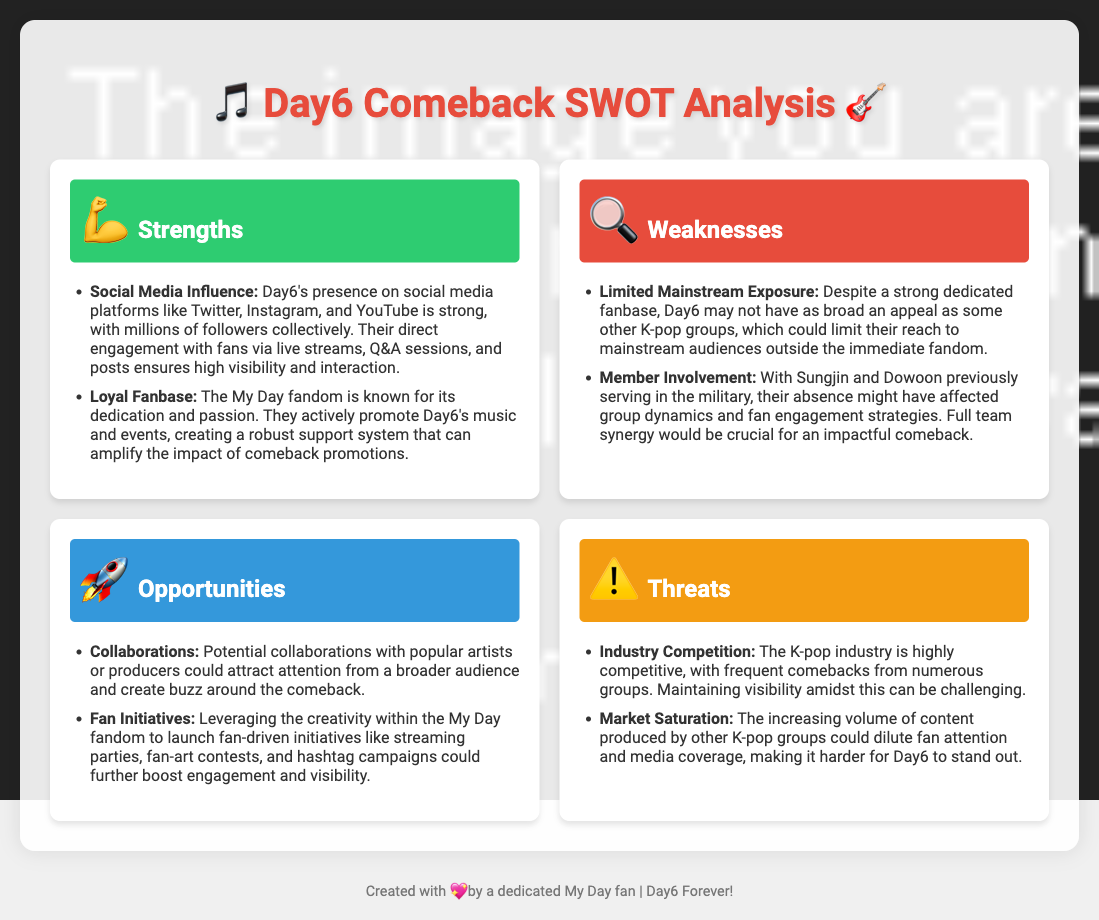what are Day6's social media platforms? The document lists Twitter, Instagram, and YouTube as Day6's social media platforms.
Answer: Twitter, Instagram, and YouTube what is a strength of Day6 regarding fan engagement? The document mentions that Day6 has a strong presence on social media which ensures high visibility and interaction with fans.
Answer: Social Media Influence how many strengths are listed in the document? The document provides two strengths under the strengths section.
Answer: 2 what is a weakness related to mainstream exposure? The document states that Day6 may not have as broad an appeal as some other K-pop groups.
Answer: Limited Mainstream Exposure what opportunity could boost Day6's visibility? The document suggests that collaborating with popular artists or producers could attract broader attention.
Answer: Collaborations how can the My Day fandom enhance fan engagement? The document mentions fan-driven initiatives like streaming parties or contests to boost engagement.
Answer: Fan Initiatives what threat is related to intense competition? The document discusses the challenge of frequent comebacks from numerous K-pop groups.
Answer: Industry Competition what is one potential threat from market dynamics? The document indicates that the increasing volume of content from other K-pop groups could dilute attention.
Answer: Market Saturation 